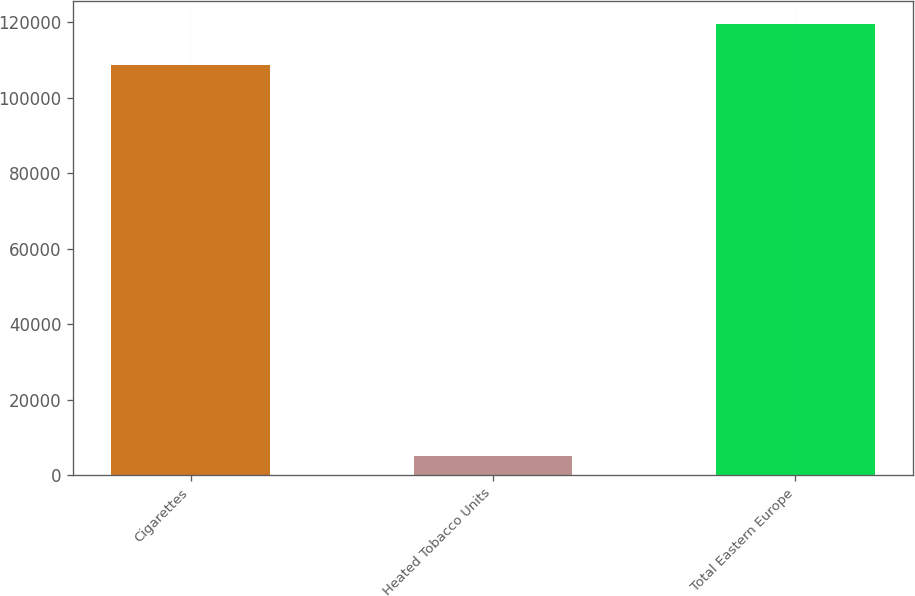Convert chart to OTSL. <chart><loc_0><loc_0><loc_500><loc_500><bar_chart><fcel>Cigarettes<fcel>Heated Tobacco Units<fcel>Total Eastern Europe<nl><fcel>108718<fcel>4979<fcel>119590<nl></chart> 